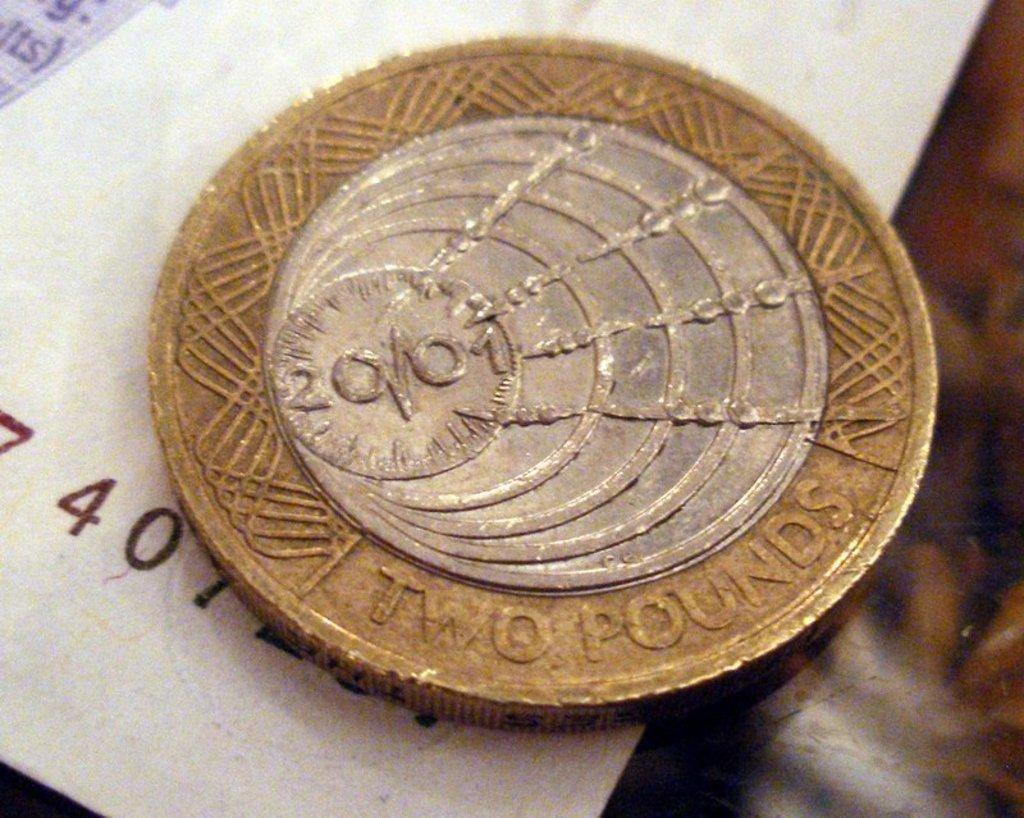Provide a one-sentence caption for the provided image. A round gold coin with a silver circle in the middle that is two pounds laying on a white piece of paper. 